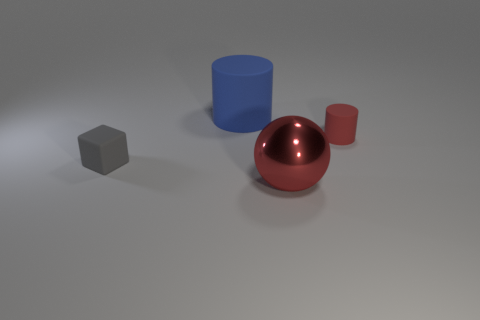Is there anything else that has the same material as the red ball?
Keep it short and to the point. No. Is there anything else that has the same shape as the large red shiny object?
Make the answer very short. No. The small cylinder that is made of the same material as the big blue object is what color?
Offer a very short reply. Red. There is a matte cylinder that is left of the shiny sphere; what is its color?
Ensure brevity in your answer.  Blue. What number of objects have the same color as the tiny matte cylinder?
Provide a succinct answer. 1. Is the number of red spheres in front of the large shiny thing less than the number of red things that are to the left of the tiny matte cylinder?
Your response must be concise. Yes. There is a large metal object; what number of tiny blocks are to the left of it?
Make the answer very short. 1. Is there a cylinder that has the same material as the tiny gray cube?
Your answer should be very brief. Yes. Is the number of gray blocks behind the big red metallic thing greater than the number of small red things on the left side of the small gray thing?
Your answer should be compact. Yes. How big is the red ball?
Make the answer very short. Large. 